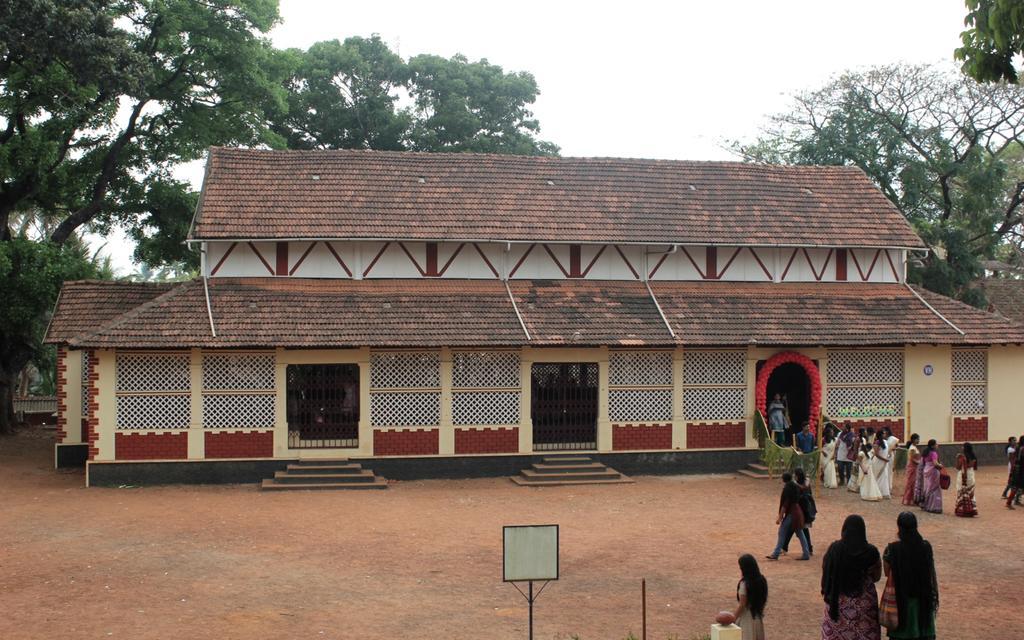Describe this image in one or two sentences. In this image I can see a building with a red color roof top and some people on the left side of the image. I can see trees on both sides of the image. At the top of the image I can see the sky. 